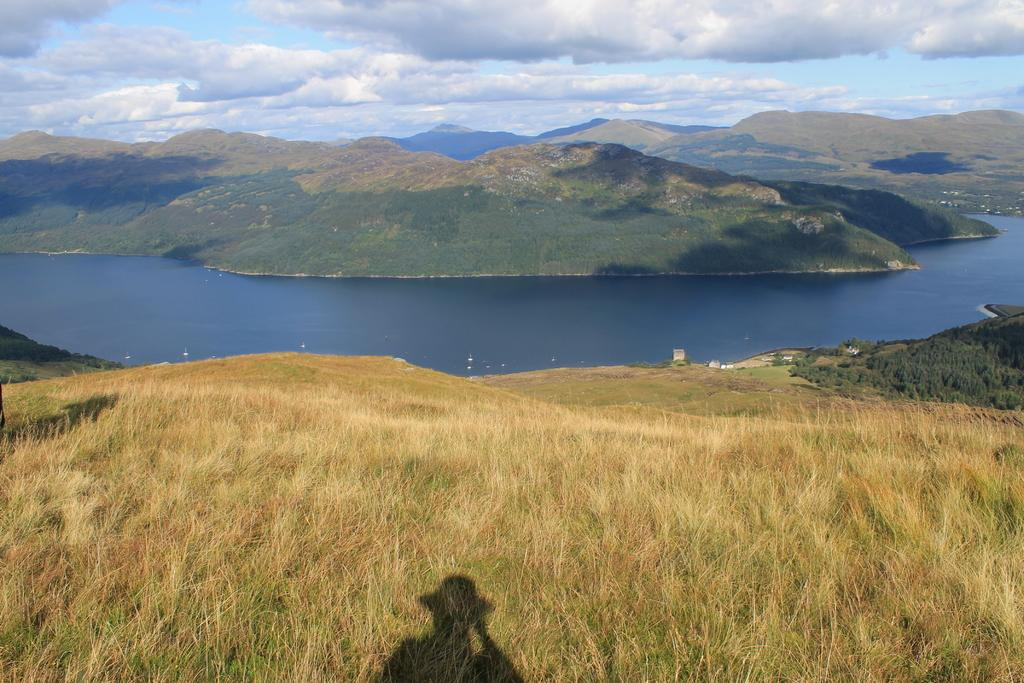What type of terrain is visible in the image? There is a hill in the image. What is covering the hill? There is grass on the hill. Can you describe any human presence in the image? There is a shadow of a person on the hill. What can be seen in the distance behind the hill? There is water visible in the background, along with hills and the sky. What is the condition of the sky in the image? The sky is visible in the background, and clouds are present. What type of car is parked at the top of the hill in the image? There is no car present in the image; it only features a hill, grass, a shadow of a person, water, hills, and the sky. What kind of haircut does the person with the shadow have in the image? There is no person visible in the image, only a shadow of a person on the hill. 